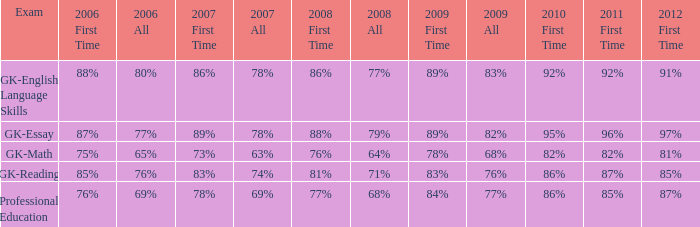What is the percentage for first time in 2012 when it was 82% for all in 2009? 97%. 